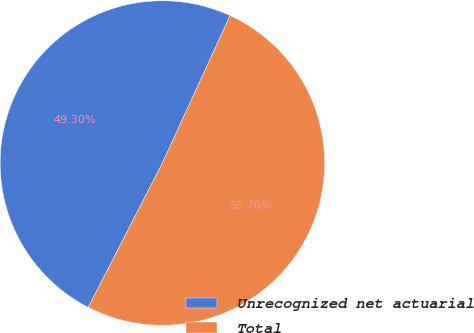Convert chart. <chart><loc_0><loc_0><loc_500><loc_500><pie_chart><fcel>Unrecognized net actuarial<fcel>Total<nl><fcel>49.3%<fcel>50.7%<nl></chart> 